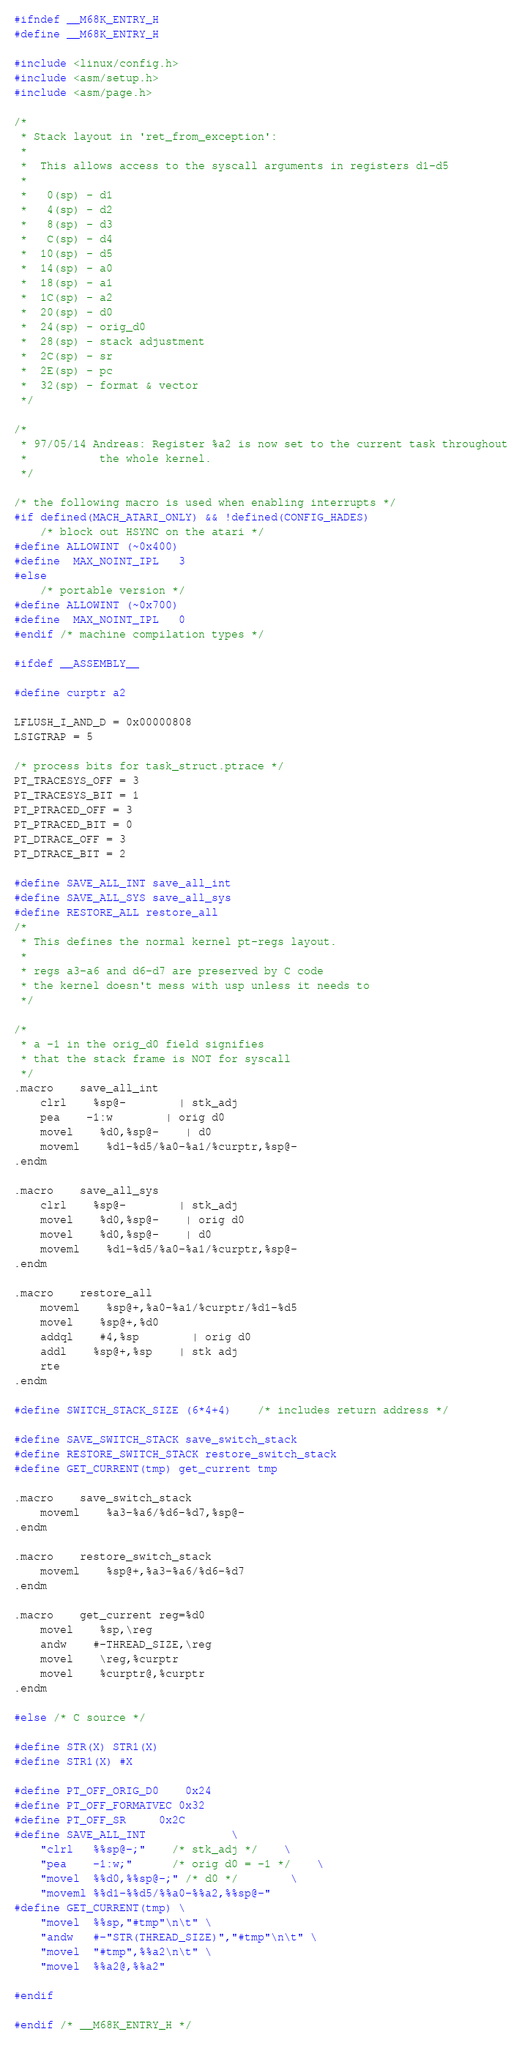<code> <loc_0><loc_0><loc_500><loc_500><_C_>#ifndef __M68K_ENTRY_H
#define __M68K_ENTRY_H

#include <linux/config.h>
#include <asm/setup.h>
#include <asm/page.h>

/*
 * Stack layout in 'ret_from_exception':
 *
 *	This allows access to the syscall arguments in registers d1-d5
 *
 *	 0(sp) - d1
 *	 4(sp) - d2
 *	 8(sp) - d3
 *	 C(sp) - d4
 *	10(sp) - d5
 *	14(sp) - a0
 *	18(sp) - a1
 *	1C(sp) - a2
 *	20(sp) - d0
 *	24(sp) - orig_d0
 *	28(sp) - stack adjustment
 *	2C(sp) - sr
 *	2E(sp) - pc
 *	32(sp) - format & vector
 */

/*
 * 97/05/14 Andreas: Register %a2 is now set to the current task throughout
 *		     the whole kernel.
 */

/* the following macro is used when enabling interrupts */
#if defined(MACH_ATARI_ONLY) && !defined(CONFIG_HADES)
	/* block out HSYNC on the atari */
#define ALLOWINT	(~0x400)
#define	MAX_NOINT_IPL	3
#else
	/* portable version */
#define ALLOWINT	(~0x700)
#define	MAX_NOINT_IPL	0
#endif /* machine compilation types */

#ifdef __ASSEMBLY__

#define curptr a2

LFLUSH_I_AND_D = 0x00000808
LSIGTRAP = 5

/* process bits for task_struct.ptrace */
PT_TRACESYS_OFF = 3
PT_TRACESYS_BIT = 1
PT_PTRACED_OFF = 3
PT_PTRACED_BIT = 0
PT_DTRACE_OFF = 3
PT_DTRACE_BIT = 2

#define SAVE_ALL_INT save_all_int
#define SAVE_ALL_SYS save_all_sys
#define RESTORE_ALL restore_all
/*
 * This defines the normal kernel pt-regs layout.
 *
 * regs a3-a6 and d6-d7 are preserved by C code
 * the kernel doesn't mess with usp unless it needs to
 */

/*
 * a -1 in the orig_d0 field signifies
 * that the stack frame is NOT for syscall
 */
.macro	save_all_int
	clrl	%sp@-		| stk_adj
	pea	-1:w		| orig d0
	movel	%d0,%sp@-	| d0
	moveml	%d1-%d5/%a0-%a1/%curptr,%sp@-
.endm

.macro	save_all_sys
	clrl	%sp@-		| stk_adj
	movel	%d0,%sp@-	| orig d0
	movel	%d0,%sp@-	| d0
	moveml	%d1-%d5/%a0-%a1/%curptr,%sp@-
.endm

.macro	restore_all
	moveml	%sp@+,%a0-%a1/%curptr/%d1-%d5
	movel	%sp@+,%d0
	addql	#4,%sp		| orig d0
	addl	%sp@+,%sp	| stk adj
	rte
.endm

#define SWITCH_STACK_SIZE (6*4+4)	/* includes return address */

#define SAVE_SWITCH_STACK save_switch_stack
#define RESTORE_SWITCH_STACK restore_switch_stack
#define GET_CURRENT(tmp) get_current tmp

.macro	save_switch_stack
	moveml	%a3-%a6/%d6-%d7,%sp@-
.endm

.macro	restore_switch_stack
	moveml	%sp@+,%a3-%a6/%d6-%d7
.endm

.macro	get_current reg=%d0
	movel	%sp,\reg
	andw	#-THREAD_SIZE,\reg
	movel	\reg,%curptr
	movel	%curptr@,%curptr
.endm

#else /* C source */

#define STR(X) STR1(X)
#define STR1(X) #X

#define PT_OFF_ORIG_D0	 0x24
#define PT_OFF_FORMATVEC 0x32
#define PT_OFF_SR	 0x2C
#define SAVE_ALL_INT				\
	"clrl	%%sp@-;"    /* stk_adj */	\
	"pea	-1:w;"	    /* orig d0 = -1 */	\
	"movel	%%d0,%%sp@-;" /* d0 */		\
	"moveml	%%d1-%%d5/%%a0-%%a2,%%sp@-"
#define GET_CURRENT(tmp) \
	"movel	%%sp,"#tmp"\n\t" \
	"andw	#-"STR(THREAD_SIZE)","#tmp"\n\t" \
	"movel	"#tmp",%%a2\n\t" \
	"movel	%%a2@,%%a2"

#endif

#endif /* __M68K_ENTRY_H */
</code> 